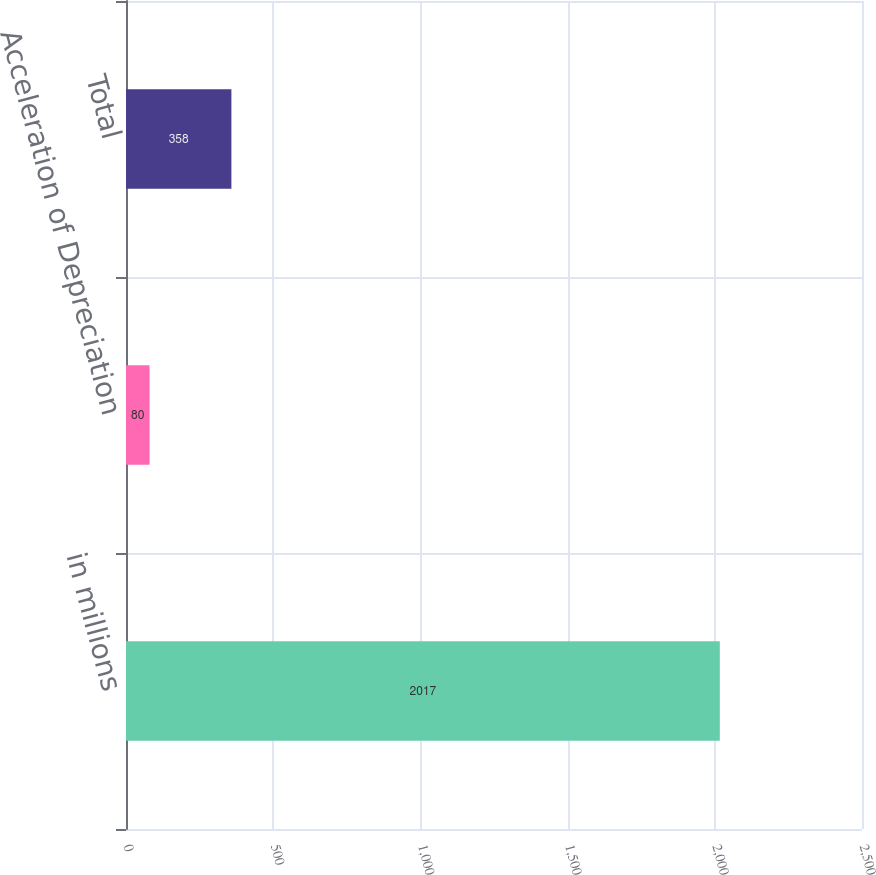<chart> <loc_0><loc_0><loc_500><loc_500><bar_chart><fcel>in millions<fcel>Acceleration of Depreciation<fcel>Total<nl><fcel>2017<fcel>80<fcel>358<nl></chart> 